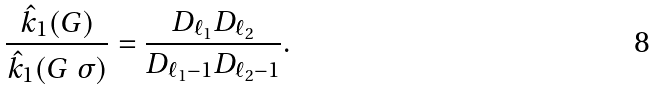Convert formula to latex. <formula><loc_0><loc_0><loc_500><loc_500>\frac { \hat { k } _ { 1 } { ( G ) } } { \hat { k } _ { 1 } ( G \ \sigma ) } = \frac { D _ { \ell _ { 1 } } D _ { \ell _ { 2 } } } { D _ { \ell _ { 1 } - 1 } D _ { \ell _ { 2 } - 1 } } .</formula> 